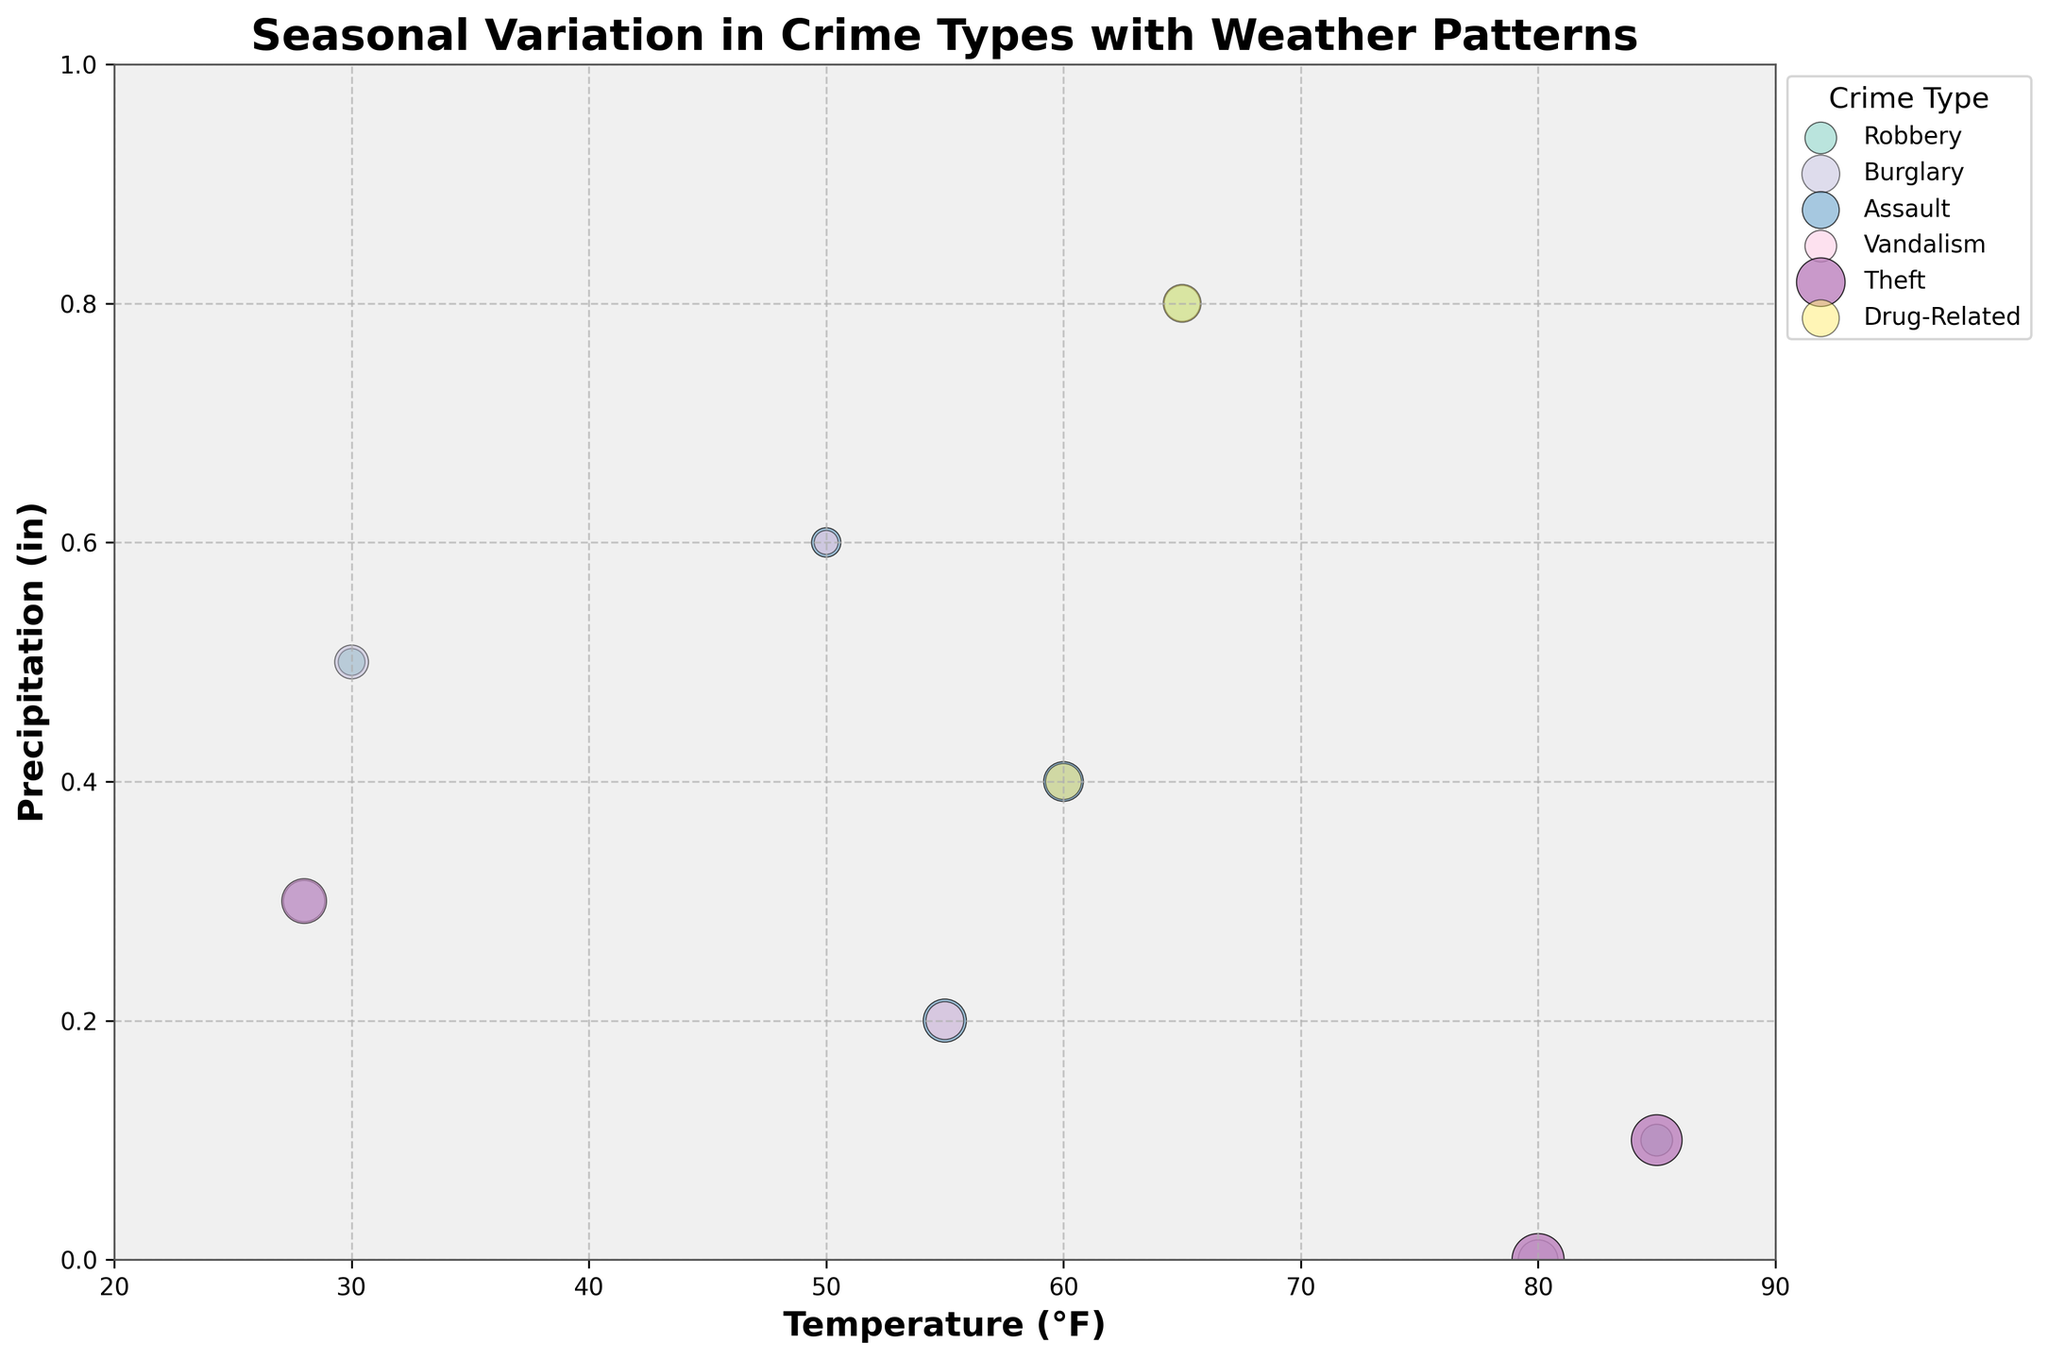How is the title of the chart written? The chart title should be checked at the top of the figure.
Answer: Seasonal Variation in Crime Types with Weather Patterns What are the x-axis and y-axis labels of the figure? Identifying the axis labels directly from the figure.
Answer: Temperature (°F), Precipitation (in) Which crime type has the highest number of occurrences when temperatures are around 80°F? Locate the point with temperatures around 80°F and compare the bubble sizes and labels.
Answer: Theft How does precipitation affect the count of Assualt crimes? Observe the transparency and size of bubbles for Assault at different precipitation levels.
Answer: Higher precipitation shows lower counts overall Which season has the most diverse types of crimes based on the given data? Identify the number of crime types in each season by looking for dates and analyzing unique crimes.
Answer: Summer What crime type occurs at the highest temperature with minimal precipitation? Check points plotted at the highest temperature (85°F) and compare precipitation and crime types.
Answer: Theft Compare the number of robbery incidents in winter vs. summer based on the plot. Locate winter (Dec-Jan) and summer (Jun-Aug) dates and compare robbery bubble sizes and counts.
Answer: Winter: 25, Summer: 35 What is the range of temperatures in which burglaries occur? Identify all bubbles labeled Burglary and extract the temperature range(°F).
Answer: 28°F to 80°F How does the transparency correlate with the crime counts in the chart? Analyze the transparency levels for larger and smaller bubbles to determine correlation.
Answer: Higher counts generally have higher transparency Which crime has the higher frequency in spring with significant precipitation? Locate points in spring months (Mar-Apr) with high precipitation and compare bubble sizes.
Answer: Assault 